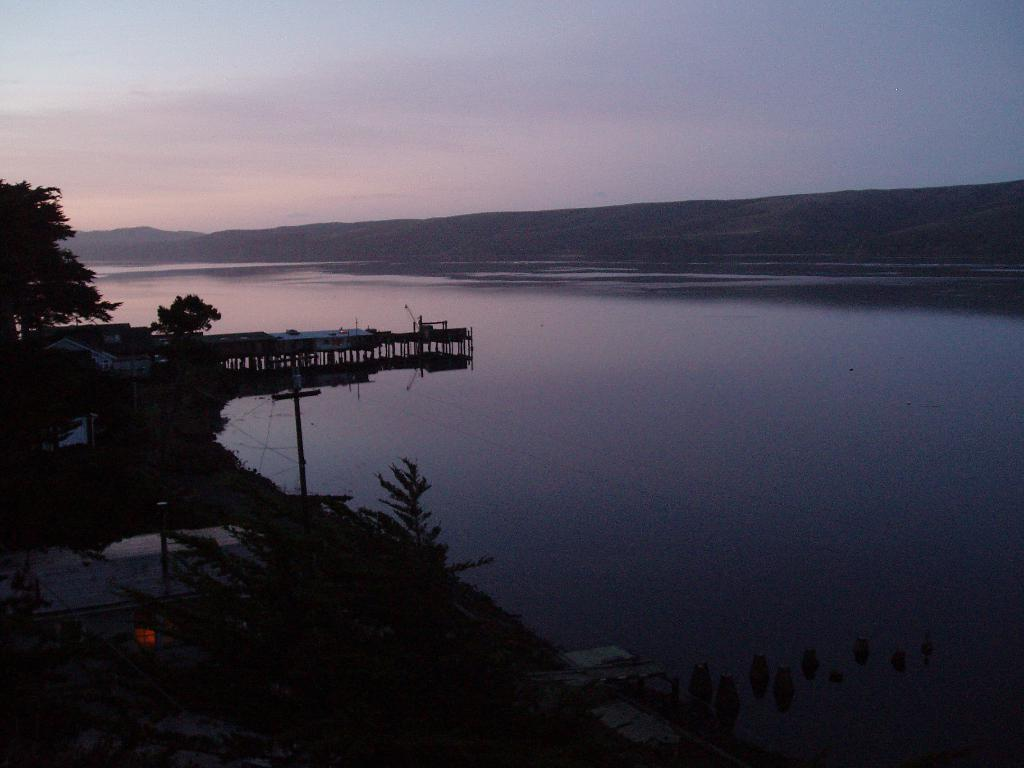What type of vegetation can be seen on the left side of the image? There are trees on the left side of the image. What is depicted in the center of the image? There is a water body in the center of the image. What structures are present in the image? There are houses and a dock in the image. What can be seen in the background of the image? There are hills in the background of the image. What is the condition of the sky in the image? The sky is partially cloudy. What type of eggnog is being served at the rest area in the image? There is no rest area or eggnog present in the image. What type of territory is being claimed by the houses in the image? The houses in the image are not claiming any territory; they are simply residential structures. 